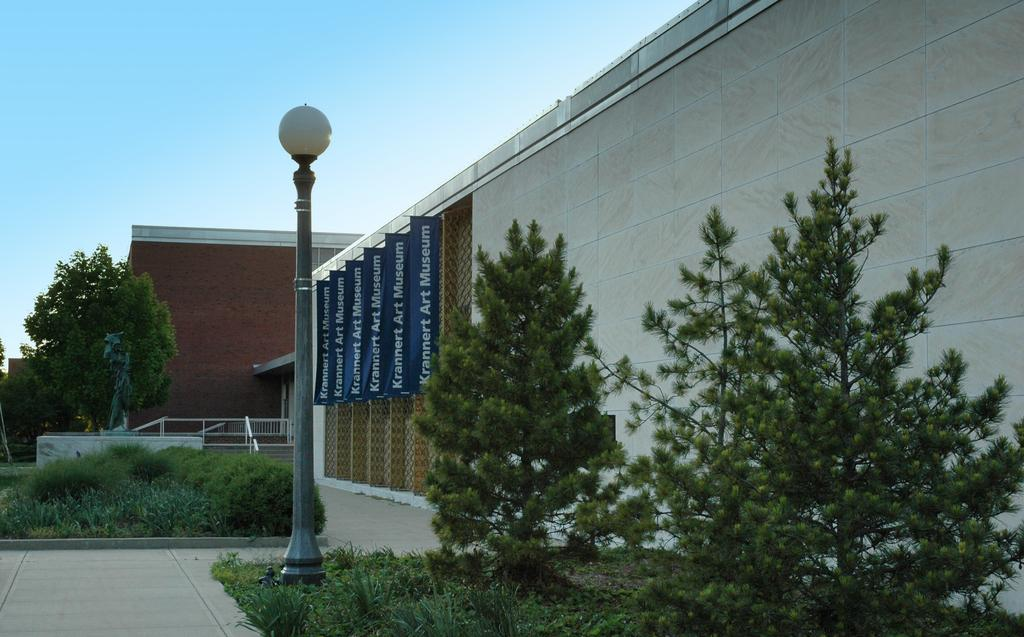What color are the boards on the wall in the image? The boards on the wall in the image are blue. What type of vegetation can be seen in the image? There are trees, plants, and grass visible in the image. What type of barrier is present in the image? There is a fence in the image. What type of structure is present in the image? There is a pole with a light in the image. What type of building is visible in the image? There is a building in the image. What can be seen in the background of the image? The sky is visible in the background of the image. Can you tell me how many cherries are hanging from the fence in the image? There are no cherries present in the image; it features a blue wall, trees, plants, grass, a fence, a pole with a light, a building, and a visible sky. Is there a trampoline visible in the image? There is no trampoline present in the image. 